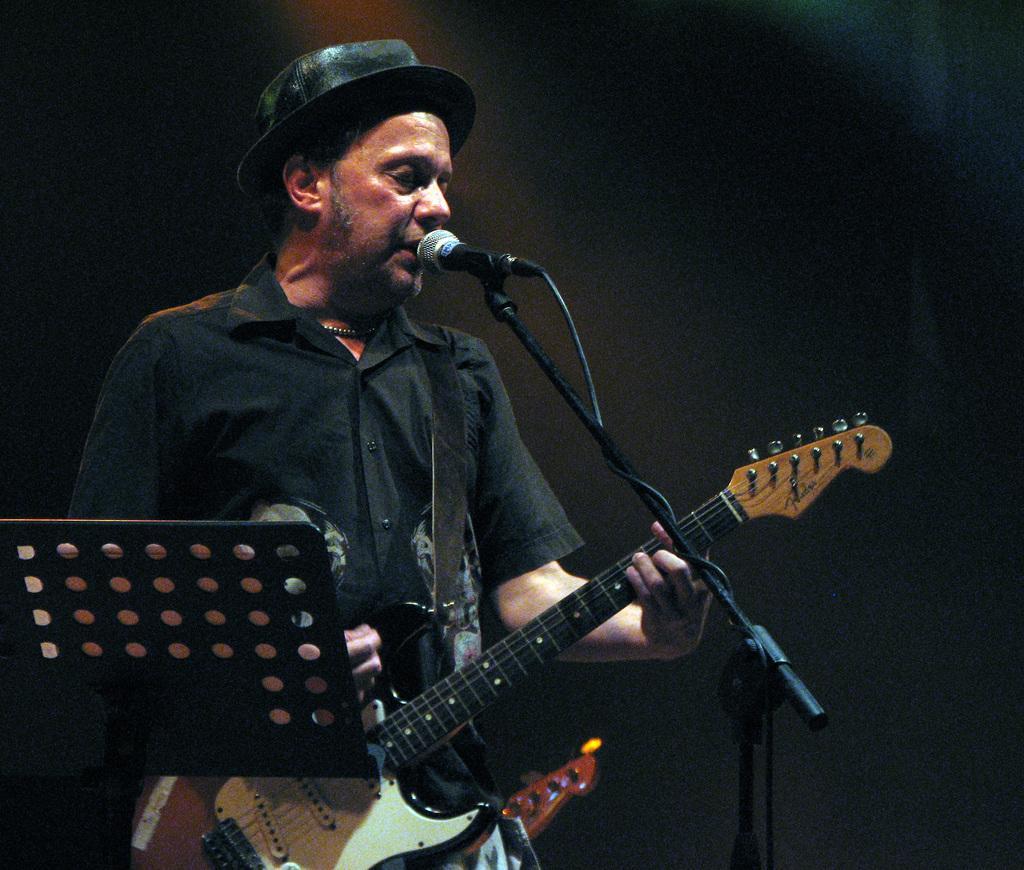Could you give a brief overview of what you see in this image? In this picture a man is playing a guitar with mic in front of him and a note is in the stand in front of him. This picture is clicked in a musical concert. The background is black in color. 